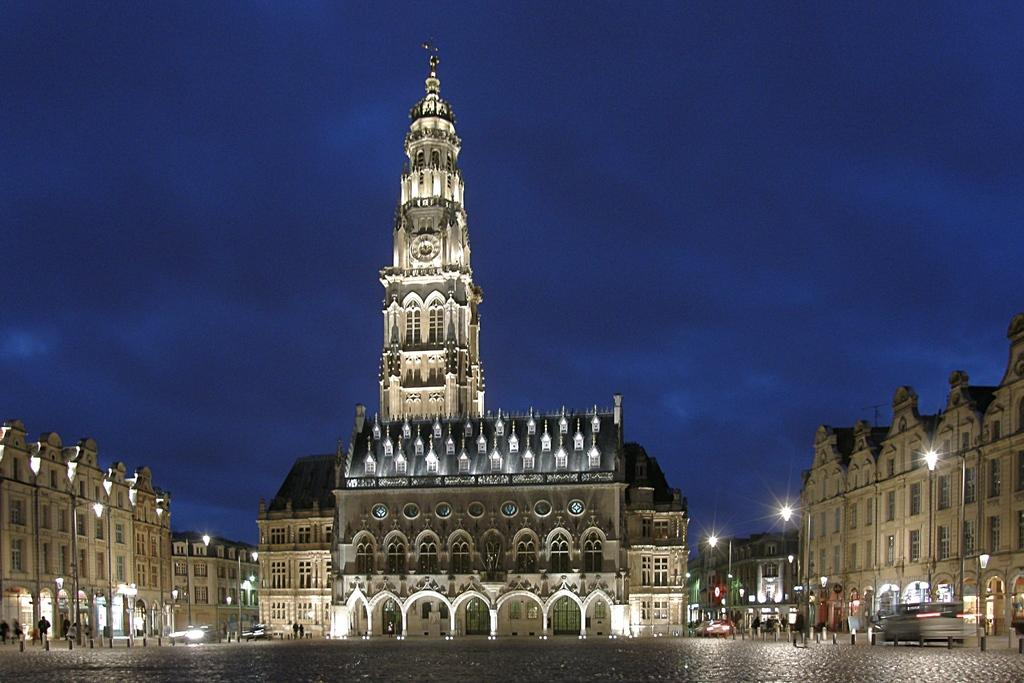How many people are in the image? There is a group of people in the image, but the exact number is not specified. What else can be seen on the road in the image? There are vehicles on the road in the image. What are the poles used for in the image? The poles in the image are likely used for supporting lights or other structures. What type of structures can be seen in the image? There are buildings and a clock tower in the image. What is visible in the background of the image? The sky is visible in the background of the image. What type of marble is used to decorate the buildings in the image? There is no mention of marble being used to decorate the buildings in the image. How many servants are attending to the committee in the image? There is no committee or servants present in the image. 